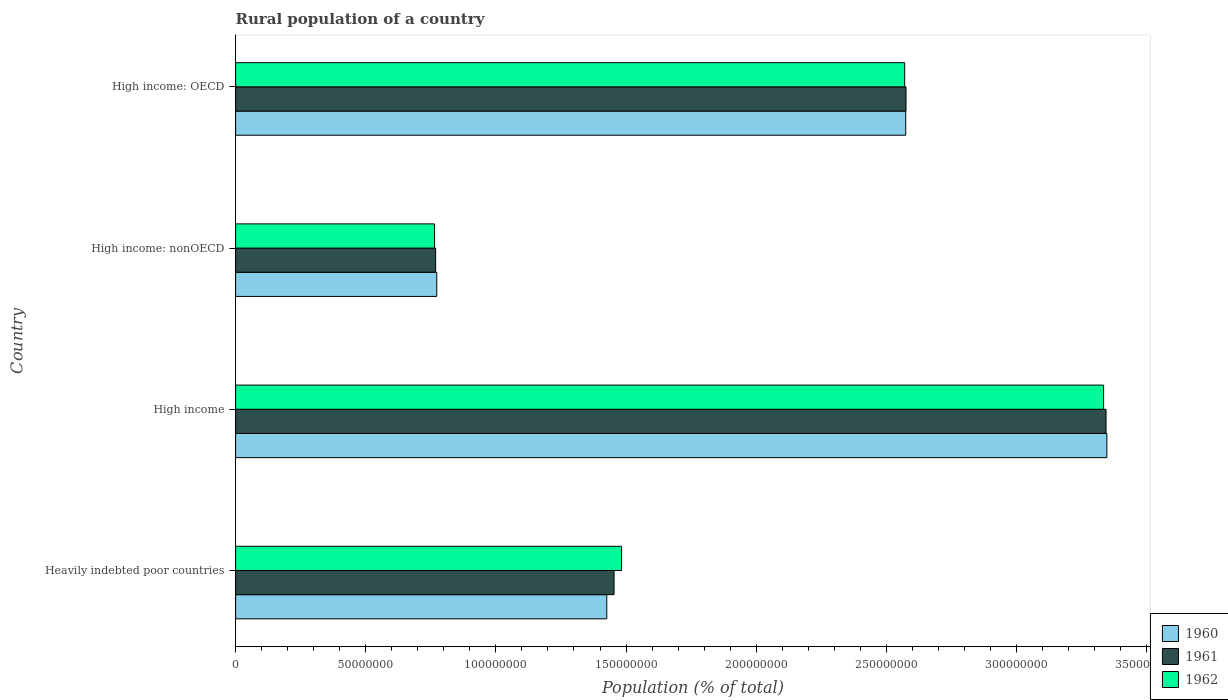How many groups of bars are there?
Give a very brief answer. 4. Are the number of bars per tick equal to the number of legend labels?
Offer a terse response. Yes. Are the number of bars on each tick of the Y-axis equal?
Make the answer very short. Yes. What is the label of the 4th group of bars from the top?
Offer a very short reply. Heavily indebted poor countries. What is the rural population in 1962 in Heavily indebted poor countries?
Your answer should be very brief. 1.48e+08. Across all countries, what is the maximum rural population in 1962?
Offer a terse response. 3.33e+08. Across all countries, what is the minimum rural population in 1961?
Your answer should be very brief. 7.69e+07. In which country was the rural population in 1960 minimum?
Your answer should be very brief. High income: nonOECD. What is the total rural population in 1961 in the graph?
Make the answer very short. 8.14e+08. What is the difference between the rural population in 1962 in High income and that in High income: OECD?
Your answer should be very brief. 7.64e+07. What is the difference between the rural population in 1960 in High income: OECD and the rural population in 1962 in High income: nonOECD?
Your answer should be compact. 1.81e+08. What is the average rural population in 1960 per country?
Provide a short and direct response. 2.03e+08. What is the difference between the rural population in 1962 and rural population in 1960 in High income: OECD?
Give a very brief answer. -4.13e+05. What is the ratio of the rural population in 1961 in Heavily indebted poor countries to that in High income: OECD?
Provide a succinct answer. 0.56. Is the rural population in 1961 in Heavily indebted poor countries less than that in High income: OECD?
Your answer should be very brief. Yes. What is the difference between the highest and the second highest rural population in 1961?
Ensure brevity in your answer.  7.69e+07. What is the difference between the highest and the lowest rural population in 1961?
Provide a short and direct response. 2.58e+08. In how many countries, is the rural population in 1961 greater than the average rural population in 1961 taken over all countries?
Give a very brief answer. 2. Is the sum of the rural population in 1960 in Heavily indebted poor countries and High income: nonOECD greater than the maximum rural population in 1961 across all countries?
Provide a succinct answer. No. What does the 1st bar from the top in Heavily indebted poor countries represents?
Ensure brevity in your answer.  1962. Is it the case that in every country, the sum of the rural population in 1962 and rural population in 1961 is greater than the rural population in 1960?
Your answer should be very brief. Yes. Are all the bars in the graph horizontal?
Make the answer very short. Yes. Does the graph contain any zero values?
Keep it short and to the point. No. Where does the legend appear in the graph?
Provide a short and direct response. Bottom right. How many legend labels are there?
Your response must be concise. 3. How are the legend labels stacked?
Keep it short and to the point. Vertical. What is the title of the graph?
Make the answer very short. Rural population of a country. Does "1968" appear as one of the legend labels in the graph?
Your response must be concise. No. What is the label or title of the X-axis?
Keep it short and to the point. Population (% of total). What is the label or title of the Y-axis?
Provide a succinct answer. Country. What is the Population (% of total) in 1960 in Heavily indebted poor countries?
Offer a very short reply. 1.43e+08. What is the Population (% of total) in 1961 in Heavily indebted poor countries?
Provide a succinct answer. 1.45e+08. What is the Population (% of total) in 1962 in Heavily indebted poor countries?
Make the answer very short. 1.48e+08. What is the Population (% of total) of 1960 in High income?
Provide a short and direct response. 3.35e+08. What is the Population (% of total) in 1961 in High income?
Your answer should be very brief. 3.34e+08. What is the Population (% of total) of 1962 in High income?
Give a very brief answer. 3.33e+08. What is the Population (% of total) in 1960 in High income: nonOECD?
Your response must be concise. 7.73e+07. What is the Population (% of total) of 1961 in High income: nonOECD?
Offer a terse response. 7.69e+07. What is the Population (% of total) of 1962 in High income: nonOECD?
Make the answer very short. 7.64e+07. What is the Population (% of total) of 1960 in High income: OECD?
Provide a succinct answer. 2.57e+08. What is the Population (% of total) of 1961 in High income: OECD?
Your answer should be compact. 2.58e+08. What is the Population (% of total) in 1962 in High income: OECD?
Offer a terse response. 2.57e+08. Across all countries, what is the maximum Population (% of total) of 1960?
Provide a short and direct response. 3.35e+08. Across all countries, what is the maximum Population (% of total) of 1961?
Your response must be concise. 3.34e+08. Across all countries, what is the maximum Population (% of total) in 1962?
Your response must be concise. 3.33e+08. Across all countries, what is the minimum Population (% of total) of 1960?
Give a very brief answer. 7.73e+07. Across all countries, what is the minimum Population (% of total) in 1961?
Your response must be concise. 7.69e+07. Across all countries, what is the minimum Population (% of total) in 1962?
Provide a succinct answer. 7.64e+07. What is the total Population (% of total) in 1960 in the graph?
Your answer should be very brief. 8.12e+08. What is the total Population (% of total) in 1961 in the graph?
Ensure brevity in your answer.  8.14e+08. What is the total Population (% of total) in 1962 in the graph?
Offer a terse response. 8.15e+08. What is the difference between the Population (% of total) in 1960 in Heavily indebted poor countries and that in High income?
Give a very brief answer. -1.92e+08. What is the difference between the Population (% of total) in 1961 in Heavily indebted poor countries and that in High income?
Make the answer very short. -1.89e+08. What is the difference between the Population (% of total) of 1962 in Heavily indebted poor countries and that in High income?
Give a very brief answer. -1.85e+08. What is the difference between the Population (% of total) of 1960 in Heavily indebted poor countries and that in High income: nonOECD?
Your response must be concise. 6.53e+07. What is the difference between the Population (% of total) of 1961 in Heavily indebted poor countries and that in High income: nonOECD?
Ensure brevity in your answer.  6.86e+07. What is the difference between the Population (% of total) in 1962 in Heavily indebted poor countries and that in High income: nonOECD?
Keep it short and to the point. 7.19e+07. What is the difference between the Population (% of total) in 1960 in Heavily indebted poor countries and that in High income: OECD?
Your answer should be compact. -1.15e+08. What is the difference between the Population (% of total) of 1961 in Heavily indebted poor countries and that in High income: OECD?
Provide a short and direct response. -1.12e+08. What is the difference between the Population (% of total) in 1962 in Heavily indebted poor countries and that in High income: OECD?
Offer a very short reply. -1.09e+08. What is the difference between the Population (% of total) of 1960 in High income and that in High income: nonOECD?
Offer a terse response. 2.57e+08. What is the difference between the Population (% of total) of 1961 in High income and that in High income: nonOECD?
Offer a terse response. 2.58e+08. What is the difference between the Population (% of total) in 1962 in High income and that in High income: nonOECD?
Your answer should be compact. 2.57e+08. What is the difference between the Population (% of total) in 1960 in High income and that in High income: OECD?
Offer a terse response. 7.73e+07. What is the difference between the Population (% of total) in 1961 in High income and that in High income: OECD?
Ensure brevity in your answer.  7.69e+07. What is the difference between the Population (% of total) of 1962 in High income and that in High income: OECD?
Provide a short and direct response. 7.64e+07. What is the difference between the Population (% of total) of 1960 in High income: nonOECD and that in High income: OECD?
Provide a short and direct response. -1.80e+08. What is the difference between the Population (% of total) of 1961 in High income: nonOECD and that in High income: OECD?
Give a very brief answer. -1.81e+08. What is the difference between the Population (% of total) in 1962 in High income: nonOECD and that in High income: OECD?
Give a very brief answer. -1.81e+08. What is the difference between the Population (% of total) in 1960 in Heavily indebted poor countries and the Population (% of total) in 1961 in High income?
Offer a terse response. -1.92e+08. What is the difference between the Population (% of total) of 1960 in Heavily indebted poor countries and the Population (% of total) of 1962 in High income?
Keep it short and to the point. -1.91e+08. What is the difference between the Population (% of total) in 1961 in Heavily indebted poor countries and the Population (% of total) in 1962 in High income?
Keep it short and to the point. -1.88e+08. What is the difference between the Population (% of total) of 1960 in Heavily indebted poor countries and the Population (% of total) of 1961 in High income: nonOECD?
Keep it short and to the point. 6.58e+07. What is the difference between the Population (% of total) of 1960 in Heavily indebted poor countries and the Population (% of total) of 1962 in High income: nonOECD?
Ensure brevity in your answer.  6.62e+07. What is the difference between the Population (% of total) of 1961 in Heavily indebted poor countries and the Population (% of total) of 1962 in High income: nonOECD?
Your answer should be compact. 6.90e+07. What is the difference between the Population (% of total) in 1960 in Heavily indebted poor countries and the Population (% of total) in 1961 in High income: OECD?
Your response must be concise. -1.15e+08. What is the difference between the Population (% of total) in 1960 in Heavily indebted poor countries and the Population (% of total) in 1962 in High income: OECD?
Make the answer very short. -1.14e+08. What is the difference between the Population (% of total) in 1961 in Heavily indebted poor countries and the Population (% of total) in 1962 in High income: OECD?
Your answer should be compact. -1.12e+08. What is the difference between the Population (% of total) of 1960 in High income and the Population (% of total) of 1961 in High income: nonOECD?
Provide a short and direct response. 2.58e+08. What is the difference between the Population (% of total) in 1960 in High income and the Population (% of total) in 1962 in High income: nonOECD?
Offer a very short reply. 2.58e+08. What is the difference between the Population (% of total) in 1961 in High income and the Population (% of total) in 1962 in High income: nonOECD?
Offer a very short reply. 2.58e+08. What is the difference between the Population (% of total) in 1960 in High income and the Population (% of total) in 1961 in High income: OECD?
Your answer should be compact. 7.72e+07. What is the difference between the Population (% of total) of 1960 in High income and the Population (% of total) of 1962 in High income: OECD?
Give a very brief answer. 7.77e+07. What is the difference between the Population (% of total) of 1961 in High income and the Population (% of total) of 1962 in High income: OECD?
Offer a terse response. 7.74e+07. What is the difference between the Population (% of total) of 1960 in High income: nonOECD and the Population (% of total) of 1961 in High income: OECD?
Provide a succinct answer. -1.80e+08. What is the difference between the Population (% of total) of 1960 in High income: nonOECD and the Population (% of total) of 1962 in High income: OECD?
Make the answer very short. -1.80e+08. What is the difference between the Population (% of total) in 1961 in High income: nonOECD and the Population (% of total) in 1962 in High income: OECD?
Provide a short and direct response. -1.80e+08. What is the average Population (% of total) of 1960 per country?
Offer a terse response. 2.03e+08. What is the average Population (% of total) of 1961 per country?
Keep it short and to the point. 2.04e+08. What is the average Population (% of total) in 1962 per country?
Make the answer very short. 2.04e+08. What is the difference between the Population (% of total) in 1960 and Population (% of total) in 1961 in Heavily indebted poor countries?
Make the answer very short. -2.80e+06. What is the difference between the Population (% of total) in 1960 and Population (% of total) in 1962 in Heavily indebted poor countries?
Keep it short and to the point. -5.68e+06. What is the difference between the Population (% of total) of 1961 and Population (% of total) of 1962 in Heavily indebted poor countries?
Make the answer very short. -2.88e+06. What is the difference between the Population (% of total) in 1960 and Population (% of total) in 1961 in High income?
Keep it short and to the point. 3.18e+05. What is the difference between the Population (% of total) in 1960 and Population (% of total) in 1962 in High income?
Your response must be concise. 1.25e+06. What is the difference between the Population (% of total) of 1961 and Population (% of total) of 1962 in High income?
Keep it short and to the point. 9.36e+05. What is the difference between the Population (% of total) in 1960 and Population (% of total) in 1961 in High income: nonOECD?
Provide a succinct answer. 4.24e+05. What is the difference between the Population (% of total) in 1960 and Population (% of total) in 1962 in High income: nonOECD?
Your answer should be very brief. 8.42e+05. What is the difference between the Population (% of total) in 1961 and Population (% of total) in 1962 in High income: nonOECD?
Your answer should be very brief. 4.18e+05. What is the difference between the Population (% of total) in 1960 and Population (% of total) in 1961 in High income: OECD?
Your response must be concise. -1.05e+05. What is the difference between the Population (% of total) of 1960 and Population (% of total) of 1962 in High income: OECD?
Keep it short and to the point. 4.13e+05. What is the difference between the Population (% of total) of 1961 and Population (% of total) of 1962 in High income: OECD?
Offer a very short reply. 5.18e+05. What is the ratio of the Population (% of total) in 1960 in Heavily indebted poor countries to that in High income?
Your answer should be compact. 0.43. What is the ratio of the Population (% of total) in 1961 in Heavily indebted poor countries to that in High income?
Offer a terse response. 0.43. What is the ratio of the Population (% of total) of 1962 in Heavily indebted poor countries to that in High income?
Make the answer very short. 0.44. What is the ratio of the Population (% of total) in 1960 in Heavily indebted poor countries to that in High income: nonOECD?
Your response must be concise. 1.85. What is the ratio of the Population (% of total) in 1961 in Heavily indebted poor countries to that in High income: nonOECD?
Your response must be concise. 1.89. What is the ratio of the Population (% of total) of 1962 in Heavily indebted poor countries to that in High income: nonOECD?
Provide a succinct answer. 1.94. What is the ratio of the Population (% of total) in 1960 in Heavily indebted poor countries to that in High income: OECD?
Offer a terse response. 0.55. What is the ratio of the Population (% of total) of 1961 in Heavily indebted poor countries to that in High income: OECD?
Offer a very short reply. 0.56. What is the ratio of the Population (% of total) in 1962 in Heavily indebted poor countries to that in High income: OECD?
Provide a short and direct response. 0.58. What is the ratio of the Population (% of total) in 1960 in High income to that in High income: nonOECD?
Offer a terse response. 4.33. What is the ratio of the Population (% of total) of 1961 in High income to that in High income: nonOECD?
Provide a short and direct response. 4.35. What is the ratio of the Population (% of total) of 1962 in High income to that in High income: nonOECD?
Provide a succinct answer. 4.36. What is the ratio of the Population (% of total) in 1960 in High income to that in High income: OECD?
Your response must be concise. 1.3. What is the ratio of the Population (% of total) in 1961 in High income to that in High income: OECD?
Offer a terse response. 1.3. What is the ratio of the Population (% of total) of 1962 in High income to that in High income: OECD?
Ensure brevity in your answer.  1.3. What is the ratio of the Population (% of total) of 1960 in High income: nonOECD to that in High income: OECD?
Ensure brevity in your answer.  0.3. What is the ratio of the Population (% of total) in 1961 in High income: nonOECD to that in High income: OECD?
Give a very brief answer. 0.3. What is the ratio of the Population (% of total) of 1962 in High income: nonOECD to that in High income: OECD?
Offer a very short reply. 0.3. What is the difference between the highest and the second highest Population (% of total) of 1960?
Your answer should be very brief. 7.73e+07. What is the difference between the highest and the second highest Population (% of total) of 1961?
Your answer should be very brief. 7.69e+07. What is the difference between the highest and the second highest Population (% of total) of 1962?
Offer a very short reply. 7.64e+07. What is the difference between the highest and the lowest Population (% of total) in 1960?
Provide a succinct answer. 2.57e+08. What is the difference between the highest and the lowest Population (% of total) of 1961?
Give a very brief answer. 2.58e+08. What is the difference between the highest and the lowest Population (% of total) in 1962?
Offer a very short reply. 2.57e+08. 